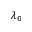<formula> <loc_0><loc_0><loc_500><loc_500>\lambda _ { 0 }</formula> 